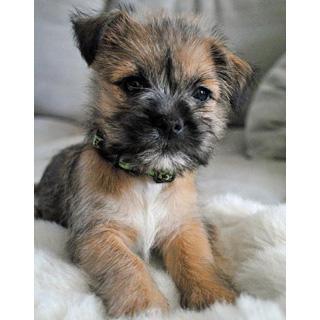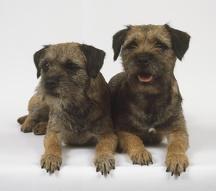The first image is the image on the left, the second image is the image on the right. Considering the images on both sides, is "The combined images contain three dogs, and one image contains a pair of similarly-posed reclining dogs." valid? Answer yes or no. Yes. The first image is the image on the left, the second image is the image on the right. Examine the images to the left and right. Is the description "In one image two dogs are laying down." accurate? Answer yes or no. Yes. 